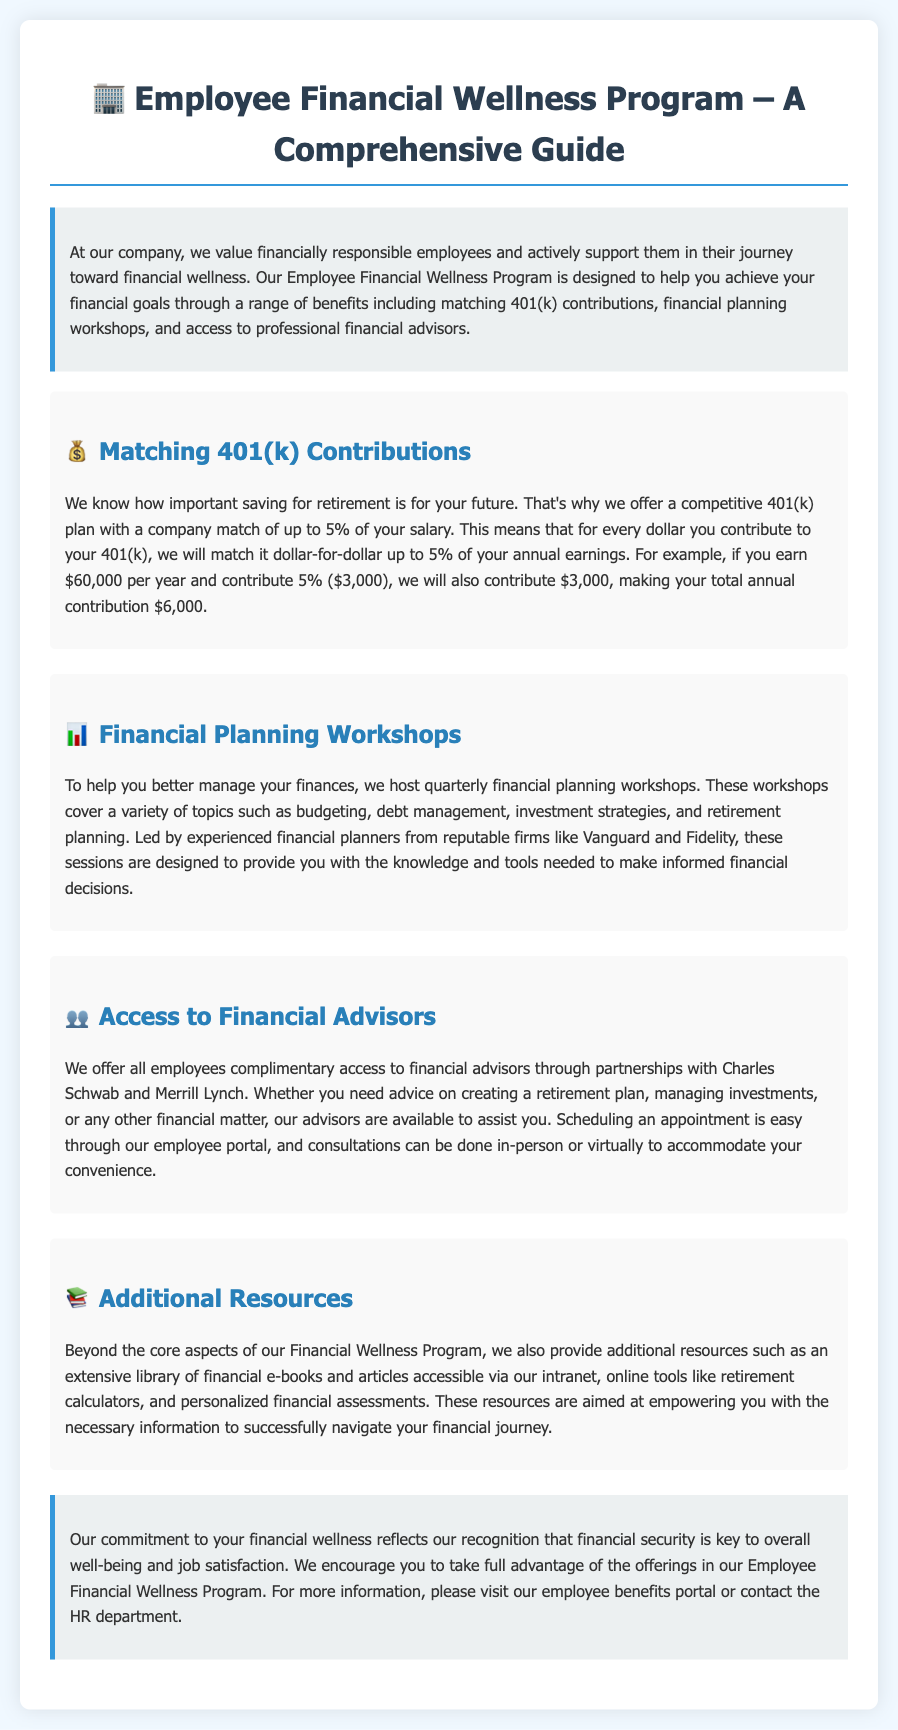What is the company match for the 401(k) contributions? The company will match dollar-for-dollar up to 5% of your annual earnings.
Answer: up to 5% What is the maximum amount the company will contribute if an employee earns $60,000 and contributes 5%? For an employee earning $60,000 contributing 5% ($3,000), the company will also contribute $3,000, making the total annual contribution $6,000.
Answer: $3,000 How often are financial planning workshops held? The workshops are hosted quarterly.
Answer: quarterly Which financial firms lead the financial planning workshops? The workshops are led by experienced financial planners from Vanguard and Fidelity.
Answer: Vanguard and Fidelity What additional resources are available to employees? The company provides an extensive library of financial e-books and articles, online tools like retirement calculators, and personalized financial assessments.
Answer: financial e-books and articles What types of consultations do financial advisors offer? Advisors assist with creating retirement plans, managing investments, or any other financial matter.
Answer: retirement plans, managing investments Where can employees schedule appointments with financial advisors? Employees can schedule appointments through the employee portal.
Answer: employee portal What is the main goal of the Employee Financial Wellness Program? The program aims to help employees achieve their financial goals.
Answer: achieve financial goals 